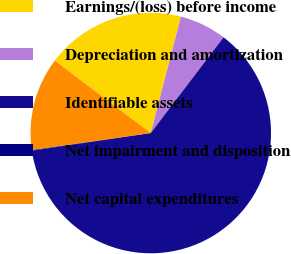Convert chart to OTSL. <chart><loc_0><loc_0><loc_500><loc_500><pie_chart><fcel>Earnings/(loss) before income<fcel>Depreciation and amortization<fcel>Identifiable assets<fcel>Net impairment and disposition<fcel>Net capital expenditures<nl><fcel>18.76%<fcel>6.31%<fcel>62.31%<fcel>0.09%<fcel>12.53%<nl></chart> 